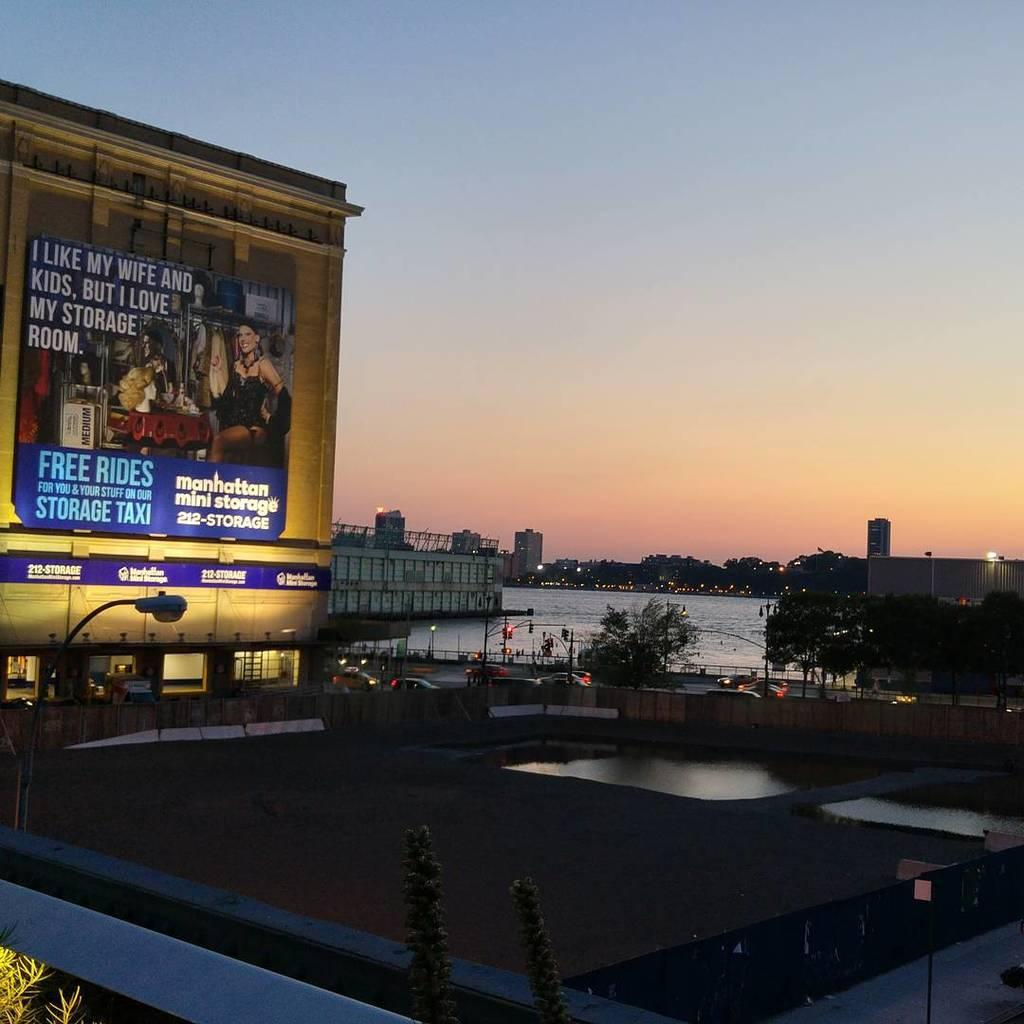<image>
Provide a brief description of the given image. A large billboard on a side of a building for Manhattan Mini Storage. 